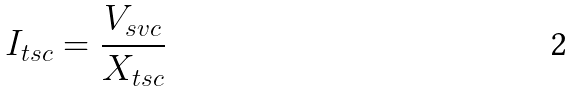Convert formula to latex. <formula><loc_0><loc_0><loc_500><loc_500>I _ { t s c } = \frac { V _ { s v c } } { X _ { t s c } }</formula> 